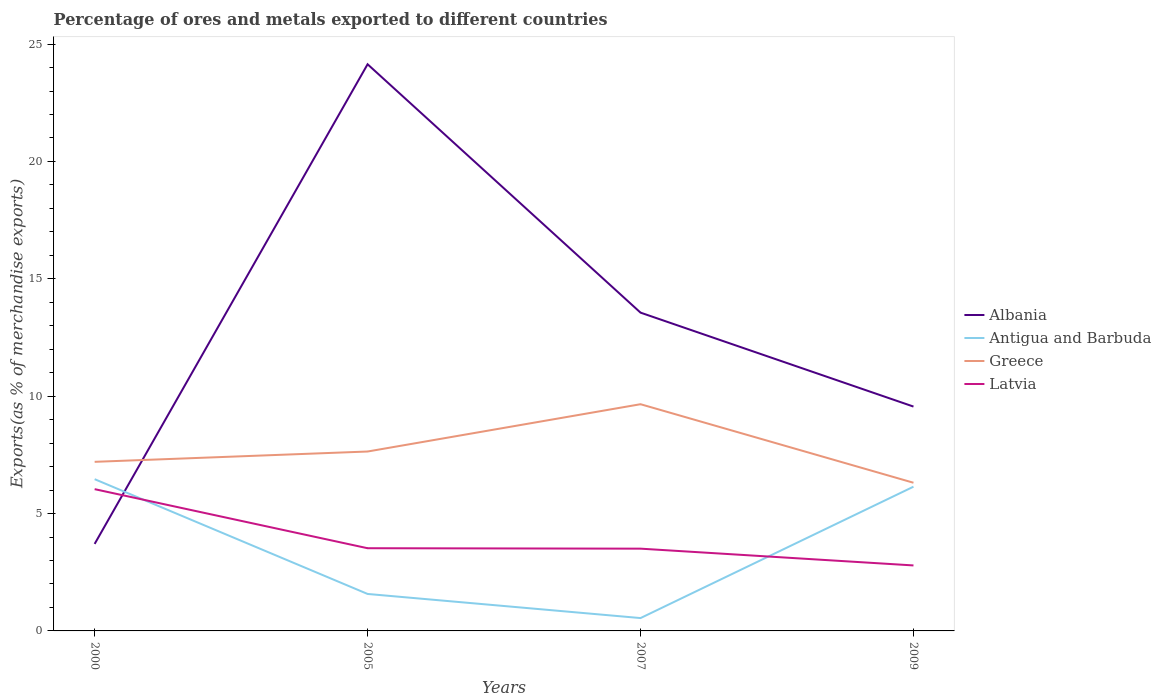Across all years, what is the maximum percentage of exports to different countries in Latvia?
Provide a short and direct response. 2.79. In which year was the percentage of exports to different countries in Greece maximum?
Provide a short and direct response. 2009. What is the total percentage of exports to different countries in Latvia in the graph?
Make the answer very short. 2.52. What is the difference between the highest and the second highest percentage of exports to different countries in Albania?
Your answer should be very brief. 20.43. What is the difference between the highest and the lowest percentage of exports to different countries in Greece?
Make the answer very short. 1. How many lines are there?
Offer a terse response. 4. What is the difference between two consecutive major ticks on the Y-axis?
Keep it short and to the point. 5. Are the values on the major ticks of Y-axis written in scientific E-notation?
Offer a terse response. No. Does the graph contain any zero values?
Provide a succinct answer. No. Does the graph contain grids?
Ensure brevity in your answer.  No. How many legend labels are there?
Make the answer very short. 4. How are the legend labels stacked?
Make the answer very short. Vertical. What is the title of the graph?
Offer a very short reply. Percentage of ores and metals exported to different countries. Does "Romania" appear as one of the legend labels in the graph?
Offer a very short reply. No. What is the label or title of the Y-axis?
Offer a terse response. Exports(as % of merchandise exports). What is the Exports(as % of merchandise exports) in Albania in 2000?
Give a very brief answer. 3.71. What is the Exports(as % of merchandise exports) of Antigua and Barbuda in 2000?
Your answer should be compact. 6.46. What is the Exports(as % of merchandise exports) in Greece in 2000?
Offer a terse response. 7.2. What is the Exports(as % of merchandise exports) in Latvia in 2000?
Offer a terse response. 6.04. What is the Exports(as % of merchandise exports) in Albania in 2005?
Give a very brief answer. 24.14. What is the Exports(as % of merchandise exports) in Antigua and Barbuda in 2005?
Provide a succinct answer. 1.57. What is the Exports(as % of merchandise exports) in Greece in 2005?
Give a very brief answer. 7.64. What is the Exports(as % of merchandise exports) in Latvia in 2005?
Offer a very short reply. 3.52. What is the Exports(as % of merchandise exports) of Albania in 2007?
Your answer should be very brief. 13.56. What is the Exports(as % of merchandise exports) in Antigua and Barbuda in 2007?
Offer a terse response. 0.55. What is the Exports(as % of merchandise exports) in Greece in 2007?
Provide a short and direct response. 9.66. What is the Exports(as % of merchandise exports) of Latvia in 2007?
Offer a very short reply. 3.5. What is the Exports(as % of merchandise exports) of Albania in 2009?
Your answer should be very brief. 9.56. What is the Exports(as % of merchandise exports) in Antigua and Barbuda in 2009?
Offer a terse response. 6.14. What is the Exports(as % of merchandise exports) in Greece in 2009?
Ensure brevity in your answer.  6.31. What is the Exports(as % of merchandise exports) of Latvia in 2009?
Keep it short and to the point. 2.79. Across all years, what is the maximum Exports(as % of merchandise exports) of Albania?
Offer a very short reply. 24.14. Across all years, what is the maximum Exports(as % of merchandise exports) in Antigua and Barbuda?
Keep it short and to the point. 6.46. Across all years, what is the maximum Exports(as % of merchandise exports) of Greece?
Your answer should be very brief. 9.66. Across all years, what is the maximum Exports(as % of merchandise exports) of Latvia?
Keep it short and to the point. 6.04. Across all years, what is the minimum Exports(as % of merchandise exports) in Albania?
Keep it short and to the point. 3.71. Across all years, what is the minimum Exports(as % of merchandise exports) of Antigua and Barbuda?
Your response must be concise. 0.55. Across all years, what is the minimum Exports(as % of merchandise exports) in Greece?
Keep it short and to the point. 6.31. Across all years, what is the minimum Exports(as % of merchandise exports) of Latvia?
Give a very brief answer. 2.79. What is the total Exports(as % of merchandise exports) in Albania in the graph?
Keep it short and to the point. 50.97. What is the total Exports(as % of merchandise exports) of Antigua and Barbuda in the graph?
Your answer should be very brief. 14.73. What is the total Exports(as % of merchandise exports) in Greece in the graph?
Your answer should be very brief. 30.82. What is the total Exports(as % of merchandise exports) in Latvia in the graph?
Ensure brevity in your answer.  15.86. What is the difference between the Exports(as % of merchandise exports) in Albania in 2000 and that in 2005?
Offer a very short reply. -20.43. What is the difference between the Exports(as % of merchandise exports) in Antigua and Barbuda in 2000 and that in 2005?
Your answer should be very brief. 4.89. What is the difference between the Exports(as % of merchandise exports) of Greece in 2000 and that in 2005?
Keep it short and to the point. -0.44. What is the difference between the Exports(as % of merchandise exports) in Latvia in 2000 and that in 2005?
Ensure brevity in your answer.  2.52. What is the difference between the Exports(as % of merchandise exports) of Albania in 2000 and that in 2007?
Give a very brief answer. -9.85. What is the difference between the Exports(as % of merchandise exports) of Antigua and Barbuda in 2000 and that in 2007?
Offer a terse response. 5.92. What is the difference between the Exports(as % of merchandise exports) of Greece in 2000 and that in 2007?
Your answer should be compact. -2.45. What is the difference between the Exports(as % of merchandise exports) of Latvia in 2000 and that in 2007?
Offer a very short reply. 2.53. What is the difference between the Exports(as % of merchandise exports) in Albania in 2000 and that in 2009?
Your answer should be very brief. -5.85. What is the difference between the Exports(as % of merchandise exports) of Antigua and Barbuda in 2000 and that in 2009?
Ensure brevity in your answer.  0.32. What is the difference between the Exports(as % of merchandise exports) in Greece in 2000 and that in 2009?
Offer a terse response. 0.89. What is the difference between the Exports(as % of merchandise exports) in Latvia in 2000 and that in 2009?
Offer a very short reply. 3.25. What is the difference between the Exports(as % of merchandise exports) in Albania in 2005 and that in 2007?
Your response must be concise. 10.58. What is the difference between the Exports(as % of merchandise exports) of Antigua and Barbuda in 2005 and that in 2007?
Keep it short and to the point. 1.03. What is the difference between the Exports(as % of merchandise exports) in Greece in 2005 and that in 2007?
Provide a succinct answer. -2.02. What is the difference between the Exports(as % of merchandise exports) in Latvia in 2005 and that in 2007?
Give a very brief answer. 0.02. What is the difference between the Exports(as % of merchandise exports) of Albania in 2005 and that in 2009?
Provide a short and direct response. 14.58. What is the difference between the Exports(as % of merchandise exports) of Antigua and Barbuda in 2005 and that in 2009?
Ensure brevity in your answer.  -4.57. What is the difference between the Exports(as % of merchandise exports) in Greece in 2005 and that in 2009?
Offer a terse response. 1.33. What is the difference between the Exports(as % of merchandise exports) of Latvia in 2005 and that in 2009?
Keep it short and to the point. 0.73. What is the difference between the Exports(as % of merchandise exports) of Albania in 2007 and that in 2009?
Your answer should be very brief. 4. What is the difference between the Exports(as % of merchandise exports) of Antigua and Barbuda in 2007 and that in 2009?
Offer a terse response. -5.6. What is the difference between the Exports(as % of merchandise exports) of Greece in 2007 and that in 2009?
Your answer should be very brief. 3.35. What is the difference between the Exports(as % of merchandise exports) of Latvia in 2007 and that in 2009?
Make the answer very short. 0.71. What is the difference between the Exports(as % of merchandise exports) of Albania in 2000 and the Exports(as % of merchandise exports) of Antigua and Barbuda in 2005?
Offer a terse response. 2.13. What is the difference between the Exports(as % of merchandise exports) of Albania in 2000 and the Exports(as % of merchandise exports) of Greece in 2005?
Your answer should be very brief. -3.94. What is the difference between the Exports(as % of merchandise exports) of Albania in 2000 and the Exports(as % of merchandise exports) of Latvia in 2005?
Offer a very short reply. 0.18. What is the difference between the Exports(as % of merchandise exports) in Antigua and Barbuda in 2000 and the Exports(as % of merchandise exports) in Greece in 2005?
Make the answer very short. -1.18. What is the difference between the Exports(as % of merchandise exports) of Antigua and Barbuda in 2000 and the Exports(as % of merchandise exports) of Latvia in 2005?
Your answer should be compact. 2.94. What is the difference between the Exports(as % of merchandise exports) of Greece in 2000 and the Exports(as % of merchandise exports) of Latvia in 2005?
Keep it short and to the point. 3.68. What is the difference between the Exports(as % of merchandise exports) in Albania in 2000 and the Exports(as % of merchandise exports) in Antigua and Barbuda in 2007?
Your answer should be compact. 3.16. What is the difference between the Exports(as % of merchandise exports) in Albania in 2000 and the Exports(as % of merchandise exports) in Greece in 2007?
Offer a terse response. -5.95. What is the difference between the Exports(as % of merchandise exports) of Albania in 2000 and the Exports(as % of merchandise exports) of Latvia in 2007?
Offer a very short reply. 0.2. What is the difference between the Exports(as % of merchandise exports) in Antigua and Barbuda in 2000 and the Exports(as % of merchandise exports) in Greece in 2007?
Give a very brief answer. -3.19. What is the difference between the Exports(as % of merchandise exports) in Antigua and Barbuda in 2000 and the Exports(as % of merchandise exports) in Latvia in 2007?
Offer a very short reply. 2.96. What is the difference between the Exports(as % of merchandise exports) in Greece in 2000 and the Exports(as % of merchandise exports) in Latvia in 2007?
Keep it short and to the point. 3.7. What is the difference between the Exports(as % of merchandise exports) in Albania in 2000 and the Exports(as % of merchandise exports) in Antigua and Barbuda in 2009?
Provide a succinct answer. -2.44. What is the difference between the Exports(as % of merchandise exports) in Albania in 2000 and the Exports(as % of merchandise exports) in Greece in 2009?
Make the answer very short. -2.61. What is the difference between the Exports(as % of merchandise exports) in Albania in 2000 and the Exports(as % of merchandise exports) in Latvia in 2009?
Your response must be concise. 0.92. What is the difference between the Exports(as % of merchandise exports) in Antigua and Barbuda in 2000 and the Exports(as % of merchandise exports) in Greece in 2009?
Keep it short and to the point. 0.15. What is the difference between the Exports(as % of merchandise exports) in Antigua and Barbuda in 2000 and the Exports(as % of merchandise exports) in Latvia in 2009?
Offer a very short reply. 3.67. What is the difference between the Exports(as % of merchandise exports) in Greece in 2000 and the Exports(as % of merchandise exports) in Latvia in 2009?
Ensure brevity in your answer.  4.41. What is the difference between the Exports(as % of merchandise exports) in Albania in 2005 and the Exports(as % of merchandise exports) in Antigua and Barbuda in 2007?
Make the answer very short. 23.59. What is the difference between the Exports(as % of merchandise exports) in Albania in 2005 and the Exports(as % of merchandise exports) in Greece in 2007?
Ensure brevity in your answer.  14.48. What is the difference between the Exports(as % of merchandise exports) in Albania in 2005 and the Exports(as % of merchandise exports) in Latvia in 2007?
Ensure brevity in your answer.  20.64. What is the difference between the Exports(as % of merchandise exports) of Antigua and Barbuda in 2005 and the Exports(as % of merchandise exports) of Greece in 2007?
Your answer should be very brief. -8.08. What is the difference between the Exports(as % of merchandise exports) in Antigua and Barbuda in 2005 and the Exports(as % of merchandise exports) in Latvia in 2007?
Provide a succinct answer. -1.93. What is the difference between the Exports(as % of merchandise exports) in Greece in 2005 and the Exports(as % of merchandise exports) in Latvia in 2007?
Make the answer very short. 4.14. What is the difference between the Exports(as % of merchandise exports) in Albania in 2005 and the Exports(as % of merchandise exports) in Antigua and Barbuda in 2009?
Your response must be concise. 18. What is the difference between the Exports(as % of merchandise exports) in Albania in 2005 and the Exports(as % of merchandise exports) in Greece in 2009?
Your answer should be compact. 17.83. What is the difference between the Exports(as % of merchandise exports) in Albania in 2005 and the Exports(as % of merchandise exports) in Latvia in 2009?
Ensure brevity in your answer.  21.35. What is the difference between the Exports(as % of merchandise exports) in Antigua and Barbuda in 2005 and the Exports(as % of merchandise exports) in Greece in 2009?
Your response must be concise. -4.74. What is the difference between the Exports(as % of merchandise exports) of Antigua and Barbuda in 2005 and the Exports(as % of merchandise exports) of Latvia in 2009?
Offer a terse response. -1.22. What is the difference between the Exports(as % of merchandise exports) in Greece in 2005 and the Exports(as % of merchandise exports) in Latvia in 2009?
Keep it short and to the point. 4.85. What is the difference between the Exports(as % of merchandise exports) in Albania in 2007 and the Exports(as % of merchandise exports) in Antigua and Barbuda in 2009?
Offer a very short reply. 7.42. What is the difference between the Exports(as % of merchandise exports) in Albania in 2007 and the Exports(as % of merchandise exports) in Greece in 2009?
Keep it short and to the point. 7.25. What is the difference between the Exports(as % of merchandise exports) in Albania in 2007 and the Exports(as % of merchandise exports) in Latvia in 2009?
Your answer should be very brief. 10.77. What is the difference between the Exports(as % of merchandise exports) of Antigua and Barbuda in 2007 and the Exports(as % of merchandise exports) of Greece in 2009?
Keep it short and to the point. -5.77. What is the difference between the Exports(as % of merchandise exports) of Antigua and Barbuda in 2007 and the Exports(as % of merchandise exports) of Latvia in 2009?
Make the answer very short. -2.24. What is the difference between the Exports(as % of merchandise exports) of Greece in 2007 and the Exports(as % of merchandise exports) of Latvia in 2009?
Offer a terse response. 6.87. What is the average Exports(as % of merchandise exports) of Albania per year?
Give a very brief answer. 12.74. What is the average Exports(as % of merchandise exports) of Antigua and Barbuda per year?
Give a very brief answer. 3.68. What is the average Exports(as % of merchandise exports) in Greece per year?
Make the answer very short. 7.7. What is the average Exports(as % of merchandise exports) of Latvia per year?
Offer a terse response. 3.96. In the year 2000, what is the difference between the Exports(as % of merchandise exports) of Albania and Exports(as % of merchandise exports) of Antigua and Barbuda?
Ensure brevity in your answer.  -2.76. In the year 2000, what is the difference between the Exports(as % of merchandise exports) of Albania and Exports(as % of merchandise exports) of Greece?
Your answer should be compact. -3.5. In the year 2000, what is the difference between the Exports(as % of merchandise exports) in Albania and Exports(as % of merchandise exports) in Latvia?
Offer a terse response. -2.33. In the year 2000, what is the difference between the Exports(as % of merchandise exports) of Antigua and Barbuda and Exports(as % of merchandise exports) of Greece?
Your answer should be compact. -0.74. In the year 2000, what is the difference between the Exports(as % of merchandise exports) of Antigua and Barbuda and Exports(as % of merchandise exports) of Latvia?
Keep it short and to the point. 0.42. In the year 2000, what is the difference between the Exports(as % of merchandise exports) of Greece and Exports(as % of merchandise exports) of Latvia?
Your response must be concise. 1.16. In the year 2005, what is the difference between the Exports(as % of merchandise exports) of Albania and Exports(as % of merchandise exports) of Antigua and Barbuda?
Make the answer very short. 22.57. In the year 2005, what is the difference between the Exports(as % of merchandise exports) of Albania and Exports(as % of merchandise exports) of Greece?
Your answer should be very brief. 16.5. In the year 2005, what is the difference between the Exports(as % of merchandise exports) of Albania and Exports(as % of merchandise exports) of Latvia?
Provide a short and direct response. 20.62. In the year 2005, what is the difference between the Exports(as % of merchandise exports) of Antigua and Barbuda and Exports(as % of merchandise exports) of Greece?
Your response must be concise. -6.07. In the year 2005, what is the difference between the Exports(as % of merchandise exports) in Antigua and Barbuda and Exports(as % of merchandise exports) in Latvia?
Offer a terse response. -1.95. In the year 2005, what is the difference between the Exports(as % of merchandise exports) in Greece and Exports(as % of merchandise exports) in Latvia?
Offer a very short reply. 4.12. In the year 2007, what is the difference between the Exports(as % of merchandise exports) in Albania and Exports(as % of merchandise exports) in Antigua and Barbuda?
Keep it short and to the point. 13.01. In the year 2007, what is the difference between the Exports(as % of merchandise exports) of Albania and Exports(as % of merchandise exports) of Greece?
Your answer should be very brief. 3.9. In the year 2007, what is the difference between the Exports(as % of merchandise exports) in Albania and Exports(as % of merchandise exports) in Latvia?
Your answer should be compact. 10.05. In the year 2007, what is the difference between the Exports(as % of merchandise exports) of Antigua and Barbuda and Exports(as % of merchandise exports) of Greece?
Provide a succinct answer. -9.11. In the year 2007, what is the difference between the Exports(as % of merchandise exports) of Antigua and Barbuda and Exports(as % of merchandise exports) of Latvia?
Give a very brief answer. -2.96. In the year 2007, what is the difference between the Exports(as % of merchandise exports) of Greece and Exports(as % of merchandise exports) of Latvia?
Offer a terse response. 6.15. In the year 2009, what is the difference between the Exports(as % of merchandise exports) of Albania and Exports(as % of merchandise exports) of Antigua and Barbuda?
Ensure brevity in your answer.  3.41. In the year 2009, what is the difference between the Exports(as % of merchandise exports) in Albania and Exports(as % of merchandise exports) in Greece?
Offer a very short reply. 3.24. In the year 2009, what is the difference between the Exports(as % of merchandise exports) of Albania and Exports(as % of merchandise exports) of Latvia?
Provide a succinct answer. 6.77. In the year 2009, what is the difference between the Exports(as % of merchandise exports) of Antigua and Barbuda and Exports(as % of merchandise exports) of Greece?
Offer a very short reply. -0.17. In the year 2009, what is the difference between the Exports(as % of merchandise exports) of Antigua and Barbuda and Exports(as % of merchandise exports) of Latvia?
Offer a very short reply. 3.35. In the year 2009, what is the difference between the Exports(as % of merchandise exports) of Greece and Exports(as % of merchandise exports) of Latvia?
Offer a terse response. 3.52. What is the ratio of the Exports(as % of merchandise exports) in Albania in 2000 to that in 2005?
Your response must be concise. 0.15. What is the ratio of the Exports(as % of merchandise exports) of Antigua and Barbuda in 2000 to that in 2005?
Your response must be concise. 4.1. What is the ratio of the Exports(as % of merchandise exports) in Greece in 2000 to that in 2005?
Ensure brevity in your answer.  0.94. What is the ratio of the Exports(as % of merchandise exports) of Latvia in 2000 to that in 2005?
Your response must be concise. 1.71. What is the ratio of the Exports(as % of merchandise exports) in Albania in 2000 to that in 2007?
Provide a short and direct response. 0.27. What is the ratio of the Exports(as % of merchandise exports) of Antigua and Barbuda in 2000 to that in 2007?
Give a very brief answer. 11.81. What is the ratio of the Exports(as % of merchandise exports) of Greece in 2000 to that in 2007?
Keep it short and to the point. 0.75. What is the ratio of the Exports(as % of merchandise exports) of Latvia in 2000 to that in 2007?
Your answer should be compact. 1.72. What is the ratio of the Exports(as % of merchandise exports) in Albania in 2000 to that in 2009?
Provide a short and direct response. 0.39. What is the ratio of the Exports(as % of merchandise exports) in Antigua and Barbuda in 2000 to that in 2009?
Offer a very short reply. 1.05. What is the ratio of the Exports(as % of merchandise exports) in Greece in 2000 to that in 2009?
Provide a short and direct response. 1.14. What is the ratio of the Exports(as % of merchandise exports) of Latvia in 2000 to that in 2009?
Your answer should be very brief. 2.16. What is the ratio of the Exports(as % of merchandise exports) in Albania in 2005 to that in 2007?
Your answer should be compact. 1.78. What is the ratio of the Exports(as % of merchandise exports) in Antigua and Barbuda in 2005 to that in 2007?
Give a very brief answer. 2.88. What is the ratio of the Exports(as % of merchandise exports) of Greece in 2005 to that in 2007?
Provide a succinct answer. 0.79. What is the ratio of the Exports(as % of merchandise exports) of Latvia in 2005 to that in 2007?
Offer a very short reply. 1.01. What is the ratio of the Exports(as % of merchandise exports) of Albania in 2005 to that in 2009?
Offer a terse response. 2.53. What is the ratio of the Exports(as % of merchandise exports) in Antigua and Barbuda in 2005 to that in 2009?
Your answer should be very brief. 0.26. What is the ratio of the Exports(as % of merchandise exports) of Greece in 2005 to that in 2009?
Your answer should be compact. 1.21. What is the ratio of the Exports(as % of merchandise exports) in Latvia in 2005 to that in 2009?
Offer a very short reply. 1.26. What is the ratio of the Exports(as % of merchandise exports) in Albania in 2007 to that in 2009?
Give a very brief answer. 1.42. What is the ratio of the Exports(as % of merchandise exports) in Antigua and Barbuda in 2007 to that in 2009?
Your response must be concise. 0.09. What is the ratio of the Exports(as % of merchandise exports) in Greece in 2007 to that in 2009?
Offer a very short reply. 1.53. What is the ratio of the Exports(as % of merchandise exports) of Latvia in 2007 to that in 2009?
Provide a short and direct response. 1.26. What is the difference between the highest and the second highest Exports(as % of merchandise exports) in Albania?
Your answer should be very brief. 10.58. What is the difference between the highest and the second highest Exports(as % of merchandise exports) in Antigua and Barbuda?
Ensure brevity in your answer.  0.32. What is the difference between the highest and the second highest Exports(as % of merchandise exports) in Greece?
Offer a terse response. 2.02. What is the difference between the highest and the second highest Exports(as % of merchandise exports) in Latvia?
Make the answer very short. 2.52. What is the difference between the highest and the lowest Exports(as % of merchandise exports) in Albania?
Your response must be concise. 20.43. What is the difference between the highest and the lowest Exports(as % of merchandise exports) of Antigua and Barbuda?
Your answer should be very brief. 5.92. What is the difference between the highest and the lowest Exports(as % of merchandise exports) of Greece?
Give a very brief answer. 3.35. What is the difference between the highest and the lowest Exports(as % of merchandise exports) in Latvia?
Ensure brevity in your answer.  3.25. 